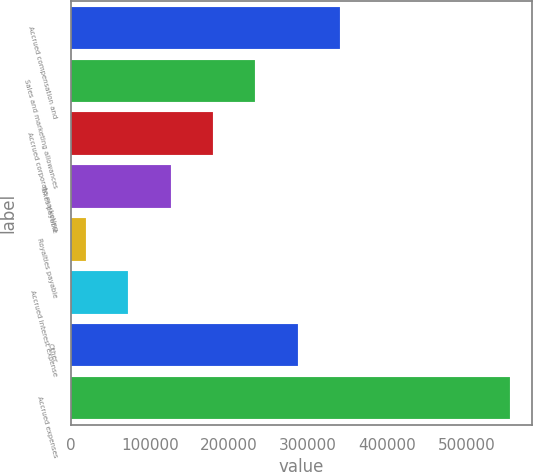<chart> <loc_0><loc_0><loc_500><loc_500><bar_chart><fcel>Accrued compensation and<fcel>Sales and marketing allowances<fcel>Accrued corporate marketing<fcel>Taxes payable<fcel>Royalties payable<fcel>Accrued interest expense<fcel>Other<fcel>Accrued expenses<nl><fcel>340476<fcel>233243<fcel>179627<fcel>126011<fcel>18778<fcel>72394.3<fcel>286860<fcel>554941<nl></chart> 